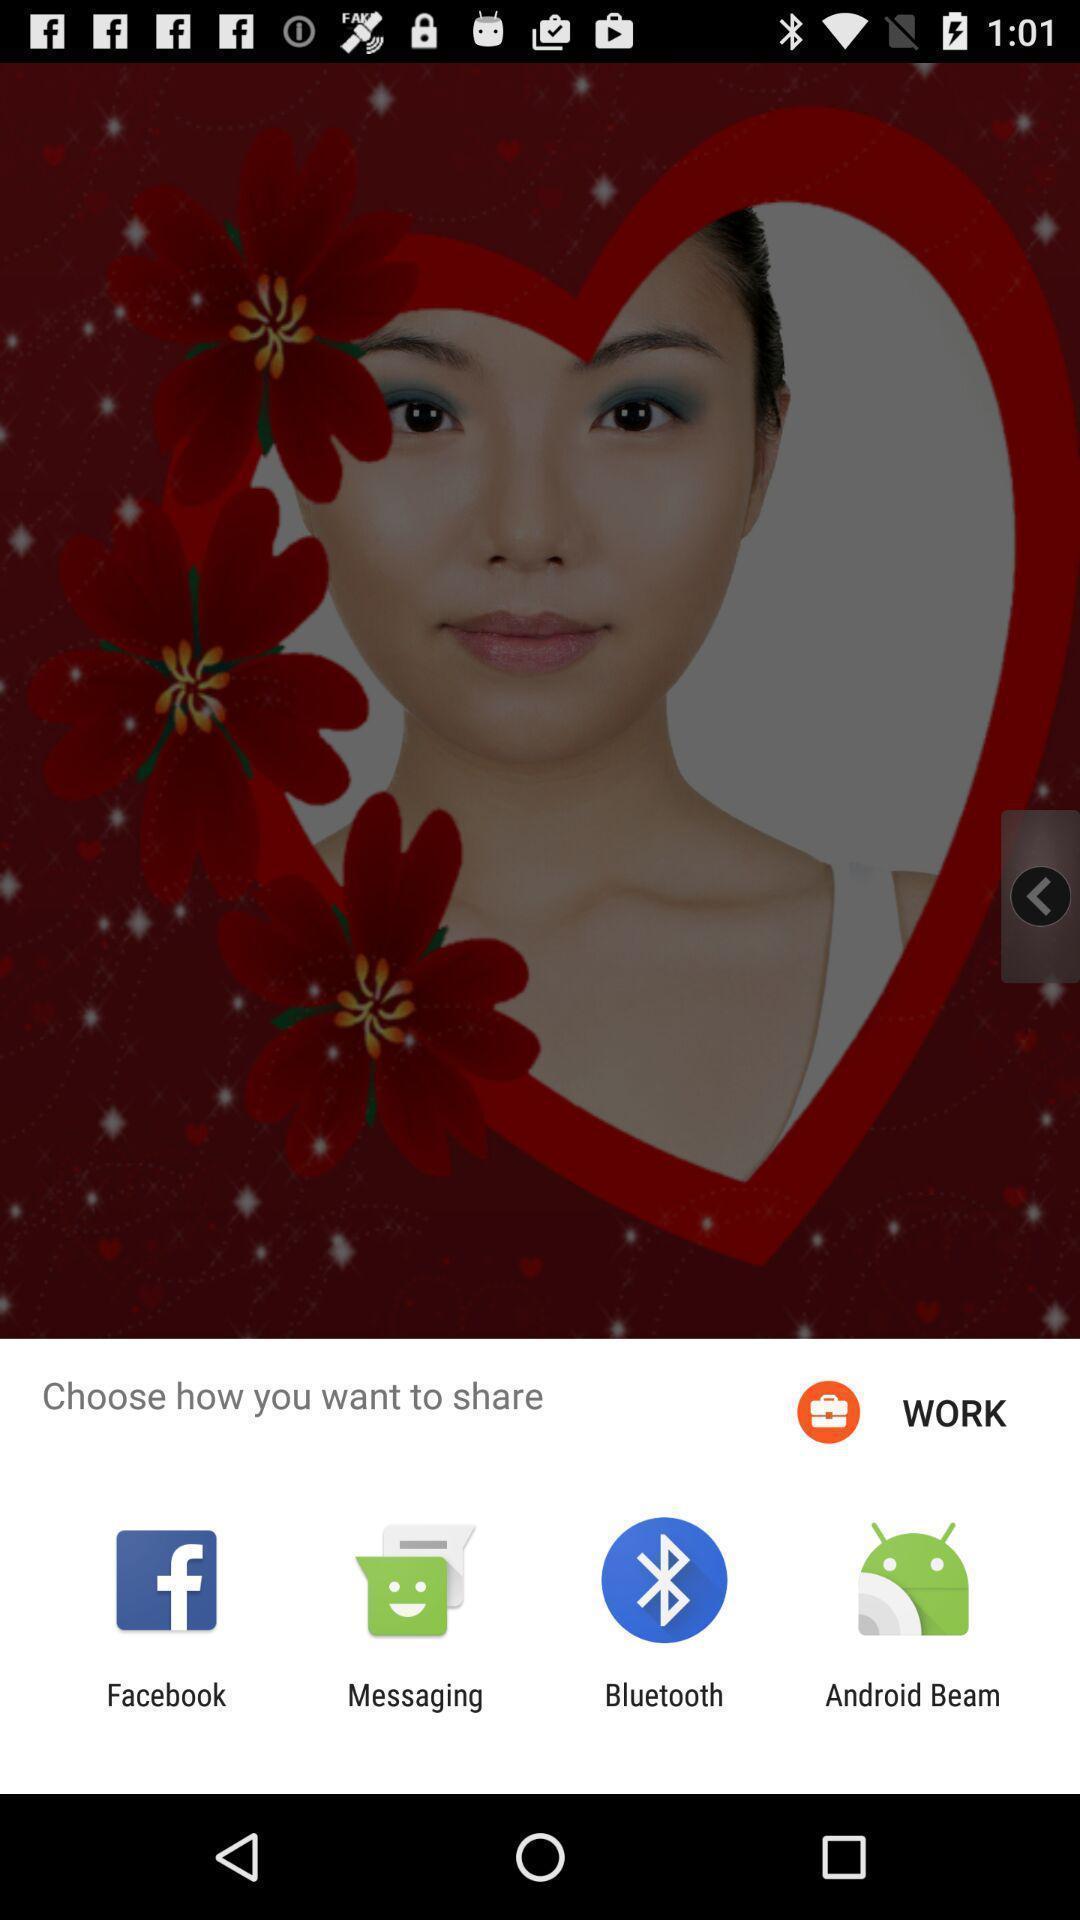Describe the key features of this screenshot. Push up message for sharing data via social network. 